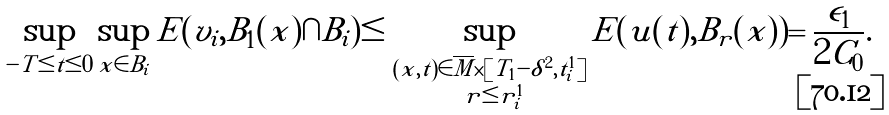<formula> <loc_0><loc_0><loc_500><loc_500>\sup _ { - T \leq t \leq 0 } \sup _ { x \in B _ { i } } E ( v _ { i } , B _ { 1 } ( x ) \cap B _ { i } ) \leq \sup _ { \substack { ( x , t ) \in \overline { M } \times [ T _ { 1 } - \delta ^ { 2 } , t _ { i } ^ { 1 } ] \\ \ r \leq r _ { i } ^ { 1 } } } E ( u ( t ) , B _ { r } ( x ) ) = \frac { \epsilon _ { 1 } } { 2 C _ { 0 } } .</formula> 